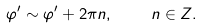<formula> <loc_0><loc_0><loc_500><loc_500>\varphi ^ { \prime } \sim \varphi ^ { \prime } + 2 \pi n , \quad \ n \in Z .</formula> 